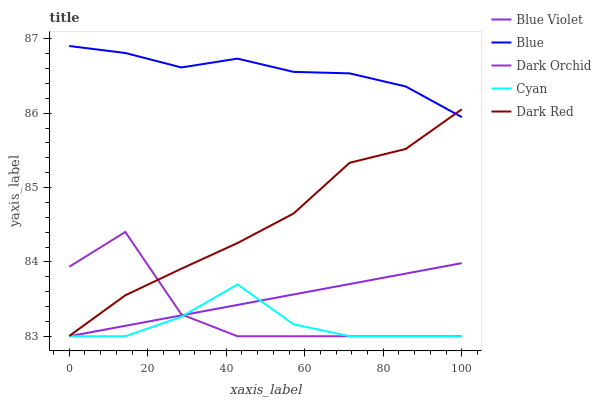Does Cyan have the minimum area under the curve?
Answer yes or no. Yes. Does Blue have the maximum area under the curve?
Answer yes or no. Yes. Does Dark Orchid have the minimum area under the curve?
Answer yes or no. No. Does Dark Orchid have the maximum area under the curve?
Answer yes or no. No. Is Blue Violet the smoothest?
Answer yes or no. Yes. Is Dark Orchid the roughest?
Answer yes or no. Yes. Is Cyan the smoothest?
Answer yes or no. No. Is Cyan the roughest?
Answer yes or no. No. Does Dark Red have the lowest value?
Answer yes or no. No. Does Dark Orchid have the highest value?
Answer yes or no. No. Is Cyan less than Dark Red?
Answer yes or no. Yes. Is Blue greater than Cyan?
Answer yes or no. Yes. Does Cyan intersect Dark Red?
Answer yes or no. No. 